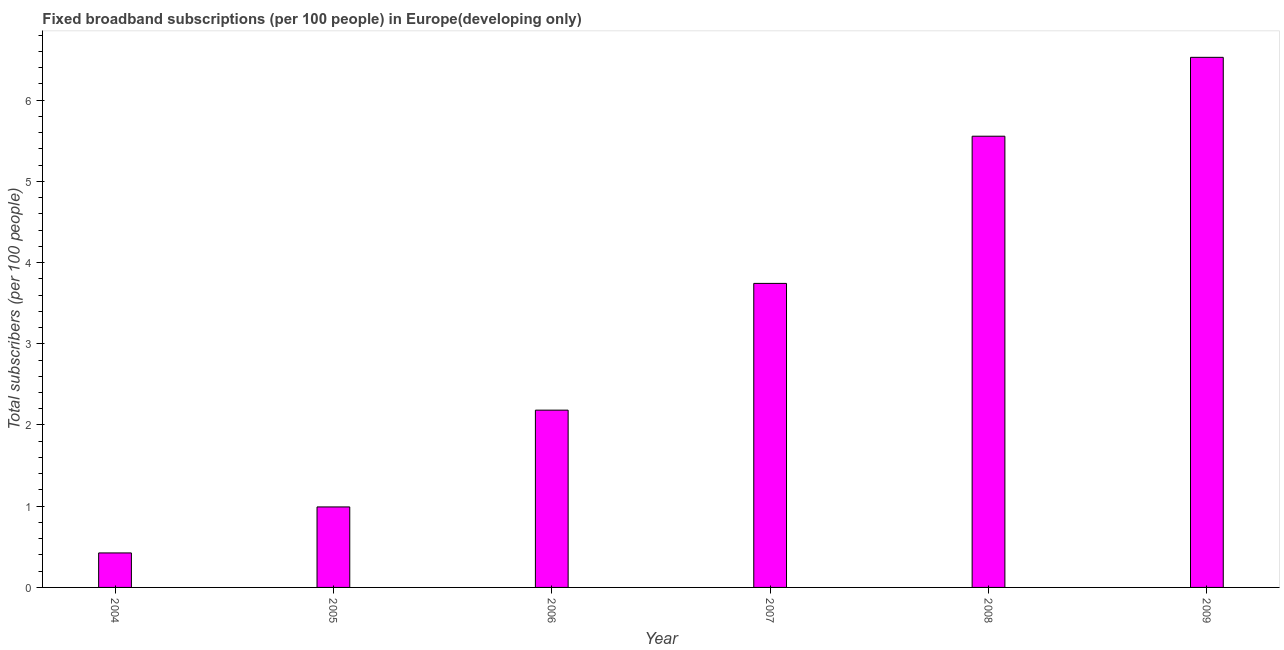What is the title of the graph?
Your response must be concise. Fixed broadband subscriptions (per 100 people) in Europe(developing only). What is the label or title of the Y-axis?
Your answer should be very brief. Total subscribers (per 100 people). What is the total number of fixed broadband subscriptions in 2007?
Make the answer very short. 3.74. Across all years, what is the maximum total number of fixed broadband subscriptions?
Offer a very short reply. 6.53. Across all years, what is the minimum total number of fixed broadband subscriptions?
Your response must be concise. 0.42. What is the sum of the total number of fixed broadband subscriptions?
Provide a short and direct response. 19.42. What is the difference between the total number of fixed broadband subscriptions in 2007 and 2008?
Make the answer very short. -1.81. What is the average total number of fixed broadband subscriptions per year?
Ensure brevity in your answer.  3.24. What is the median total number of fixed broadband subscriptions?
Your answer should be very brief. 2.96. In how many years, is the total number of fixed broadband subscriptions greater than 4 ?
Offer a very short reply. 2. Do a majority of the years between 2006 and 2007 (inclusive) have total number of fixed broadband subscriptions greater than 6.2 ?
Keep it short and to the point. No. What is the ratio of the total number of fixed broadband subscriptions in 2004 to that in 2006?
Offer a very short reply. 0.2. Is the total number of fixed broadband subscriptions in 2007 less than that in 2008?
Offer a terse response. Yes. Is the difference between the total number of fixed broadband subscriptions in 2004 and 2006 greater than the difference between any two years?
Provide a succinct answer. No. Is the sum of the total number of fixed broadband subscriptions in 2006 and 2009 greater than the maximum total number of fixed broadband subscriptions across all years?
Offer a very short reply. Yes. What is the difference between the highest and the lowest total number of fixed broadband subscriptions?
Give a very brief answer. 6.1. In how many years, is the total number of fixed broadband subscriptions greater than the average total number of fixed broadband subscriptions taken over all years?
Your answer should be compact. 3. What is the difference between two consecutive major ticks on the Y-axis?
Provide a succinct answer. 1. Are the values on the major ticks of Y-axis written in scientific E-notation?
Make the answer very short. No. What is the Total subscribers (per 100 people) of 2004?
Make the answer very short. 0.42. What is the Total subscribers (per 100 people) of 2005?
Provide a succinct answer. 0.99. What is the Total subscribers (per 100 people) of 2006?
Give a very brief answer. 2.18. What is the Total subscribers (per 100 people) in 2007?
Provide a short and direct response. 3.74. What is the Total subscribers (per 100 people) in 2008?
Offer a very short reply. 5.56. What is the Total subscribers (per 100 people) of 2009?
Give a very brief answer. 6.53. What is the difference between the Total subscribers (per 100 people) in 2004 and 2005?
Provide a succinct answer. -0.57. What is the difference between the Total subscribers (per 100 people) in 2004 and 2006?
Provide a succinct answer. -1.76. What is the difference between the Total subscribers (per 100 people) in 2004 and 2007?
Ensure brevity in your answer.  -3.32. What is the difference between the Total subscribers (per 100 people) in 2004 and 2008?
Your answer should be compact. -5.13. What is the difference between the Total subscribers (per 100 people) in 2004 and 2009?
Your answer should be compact. -6.1. What is the difference between the Total subscribers (per 100 people) in 2005 and 2006?
Your answer should be compact. -1.19. What is the difference between the Total subscribers (per 100 people) in 2005 and 2007?
Your response must be concise. -2.75. What is the difference between the Total subscribers (per 100 people) in 2005 and 2008?
Offer a very short reply. -4.56. What is the difference between the Total subscribers (per 100 people) in 2005 and 2009?
Your answer should be compact. -5.54. What is the difference between the Total subscribers (per 100 people) in 2006 and 2007?
Offer a very short reply. -1.56. What is the difference between the Total subscribers (per 100 people) in 2006 and 2008?
Give a very brief answer. -3.37. What is the difference between the Total subscribers (per 100 people) in 2006 and 2009?
Your response must be concise. -4.34. What is the difference between the Total subscribers (per 100 people) in 2007 and 2008?
Keep it short and to the point. -1.81. What is the difference between the Total subscribers (per 100 people) in 2007 and 2009?
Your answer should be very brief. -2.78. What is the difference between the Total subscribers (per 100 people) in 2008 and 2009?
Your response must be concise. -0.97. What is the ratio of the Total subscribers (per 100 people) in 2004 to that in 2005?
Provide a succinct answer. 0.43. What is the ratio of the Total subscribers (per 100 people) in 2004 to that in 2006?
Offer a very short reply. 0.2. What is the ratio of the Total subscribers (per 100 people) in 2004 to that in 2007?
Provide a short and direct response. 0.11. What is the ratio of the Total subscribers (per 100 people) in 2004 to that in 2008?
Offer a terse response. 0.08. What is the ratio of the Total subscribers (per 100 people) in 2004 to that in 2009?
Your response must be concise. 0.07. What is the ratio of the Total subscribers (per 100 people) in 2005 to that in 2006?
Offer a very short reply. 0.45. What is the ratio of the Total subscribers (per 100 people) in 2005 to that in 2007?
Give a very brief answer. 0.27. What is the ratio of the Total subscribers (per 100 people) in 2005 to that in 2008?
Give a very brief answer. 0.18. What is the ratio of the Total subscribers (per 100 people) in 2005 to that in 2009?
Keep it short and to the point. 0.15. What is the ratio of the Total subscribers (per 100 people) in 2006 to that in 2007?
Ensure brevity in your answer.  0.58. What is the ratio of the Total subscribers (per 100 people) in 2006 to that in 2008?
Give a very brief answer. 0.39. What is the ratio of the Total subscribers (per 100 people) in 2006 to that in 2009?
Offer a very short reply. 0.33. What is the ratio of the Total subscribers (per 100 people) in 2007 to that in 2008?
Provide a short and direct response. 0.67. What is the ratio of the Total subscribers (per 100 people) in 2007 to that in 2009?
Offer a very short reply. 0.57. What is the ratio of the Total subscribers (per 100 people) in 2008 to that in 2009?
Offer a very short reply. 0.85. 